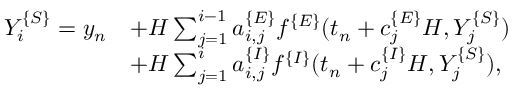<formula> <loc_0><loc_0><loc_500><loc_500>\begin{array} { r l } { Y _ { i } ^ { \{ S \} } = y _ { n } } & { + H \sum _ { j = 1 } ^ { i - 1 } a _ { i , j } ^ { \{ E \} } f ^ { \{ E \} } ( t _ { n } + c _ { j } ^ { \{ E \} } H , Y _ { j } ^ { \{ S \} } ) } \\ & { + H \sum _ { j = 1 } ^ { i } a _ { i , j } ^ { \{ I \} } f ^ { \{ I \} } ( t _ { n } + c _ { j } ^ { \{ I \} } H , Y _ { j } ^ { \{ S \} } ) , } \end{array}</formula> 